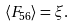Convert formula to latex. <formula><loc_0><loc_0><loc_500><loc_500>\langle F _ { 5 6 } \rangle = \xi .</formula> 